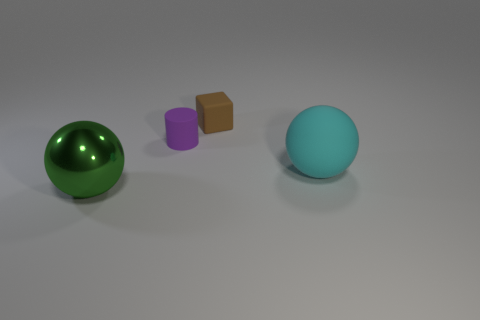Add 4 brown rubber blocks. How many objects exist? 8 Subtract all cylinders. How many objects are left? 3 Subtract all rubber things. Subtract all gray shiny cylinders. How many objects are left? 1 Add 3 purple rubber cylinders. How many purple rubber cylinders are left? 4 Add 1 tiny gray rubber objects. How many tiny gray rubber objects exist? 1 Subtract 1 cyan balls. How many objects are left? 3 